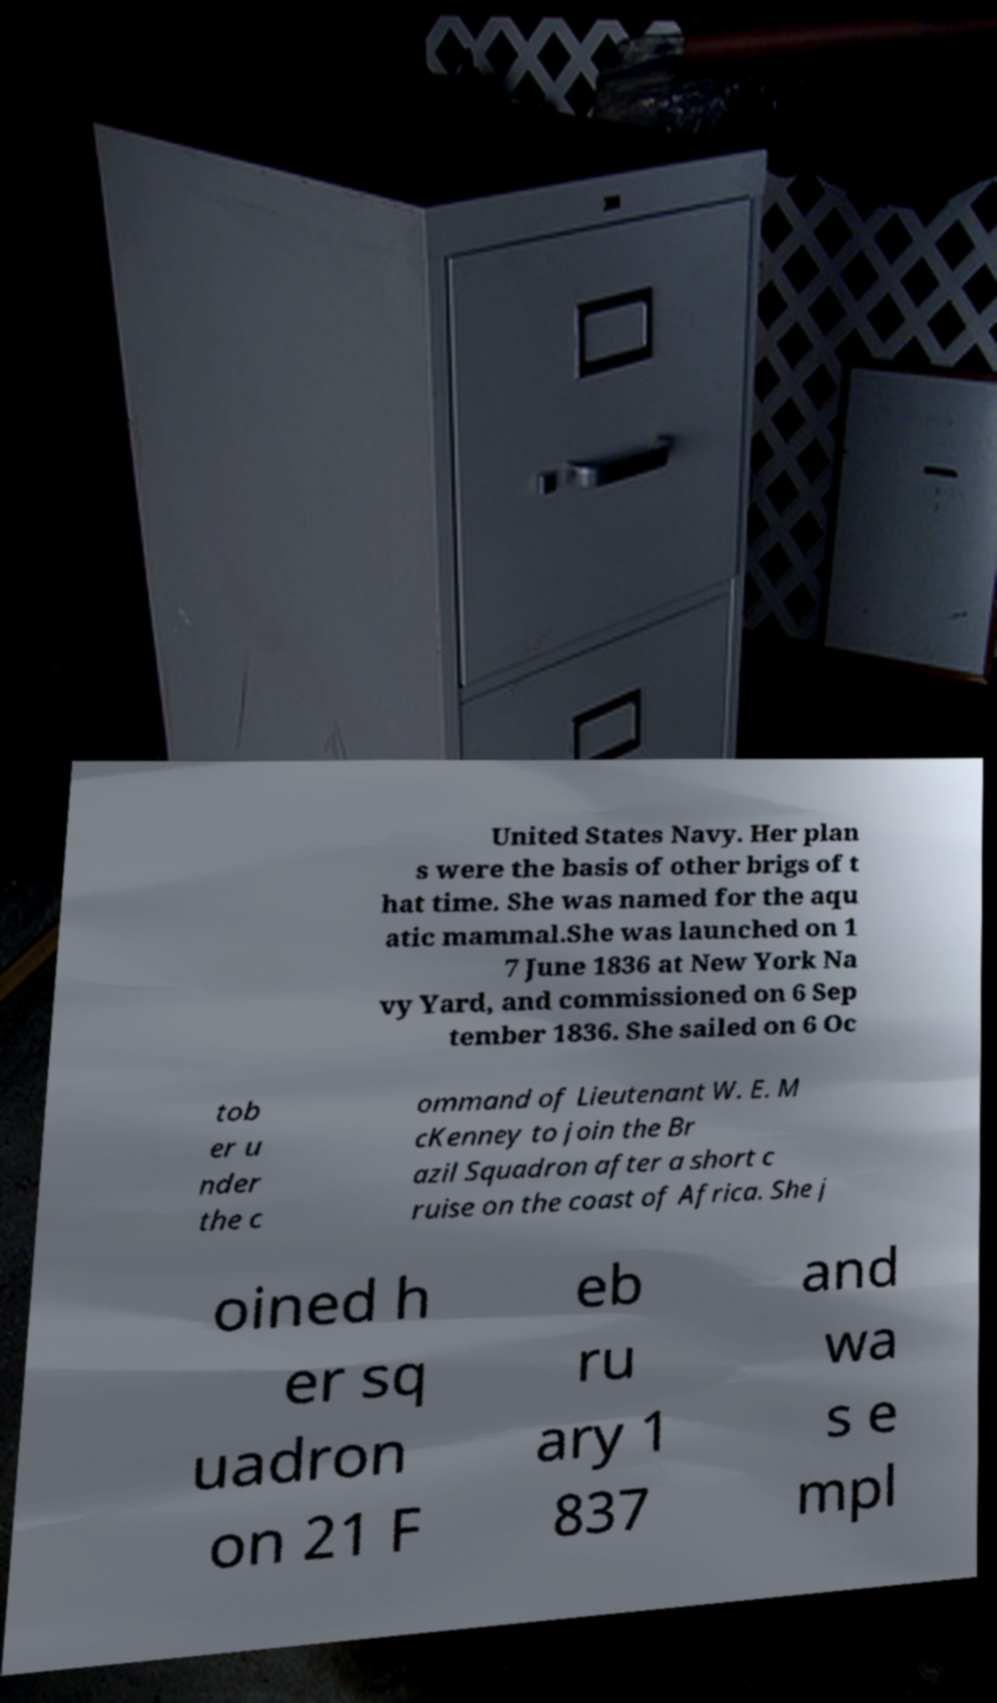What messages or text are displayed in this image? I need them in a readable, typed format. United States Navy. Her plan s were the basis of other brigs of t hat time. She was named for the aqu atic mammal.She was launched on 1 7 June 1836 at New York Na vy Yard, and commissioned on 6 Sep tember 1836. She sailed on 6 Oc tob er u nder the c ommand of Lieutenant W. E. M cKenney to join the Br azil Squadron after a short c ruise on the coast of Africa. She j oined h er sq uadron on 21 F eb ru ary 1 837 and wa s e mpl 